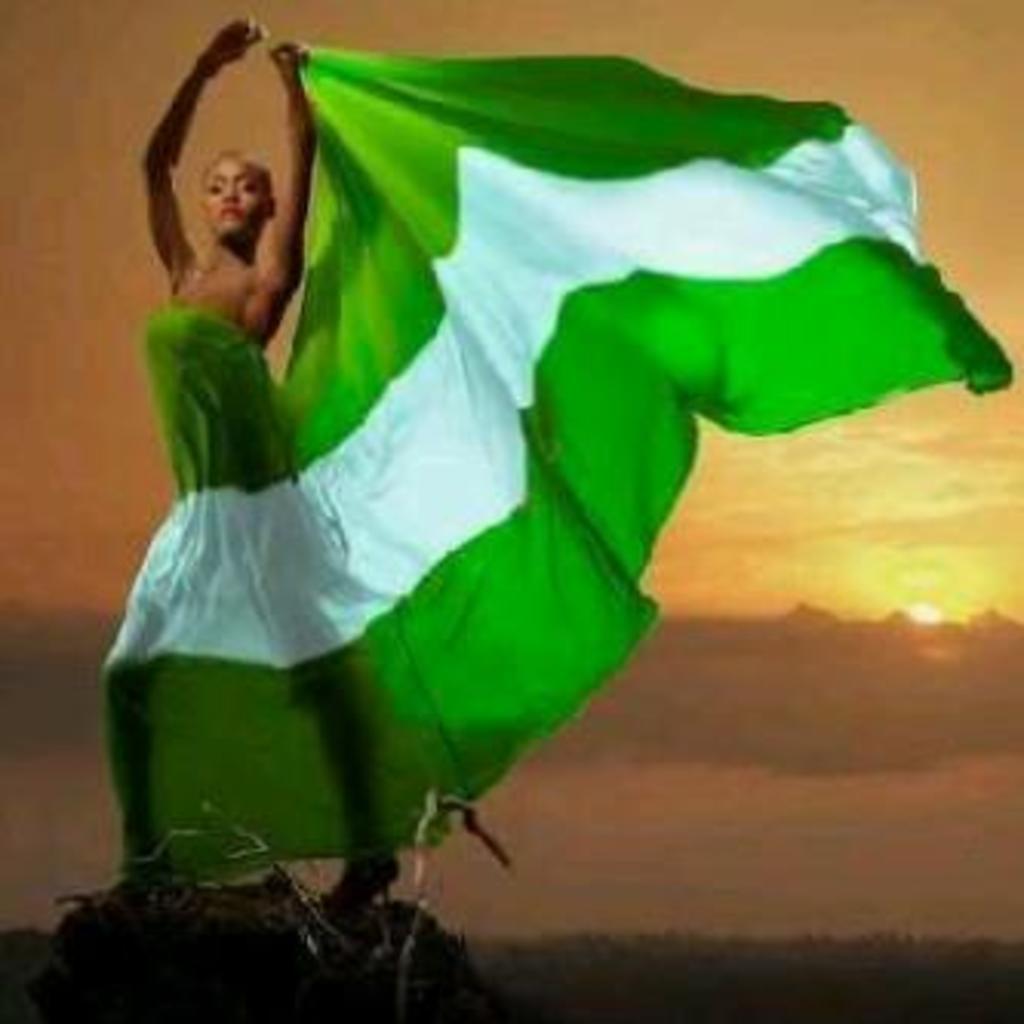Could you give a brief overview of what you see in this image? In this image we can see a lady standing. In the back there is sky. 